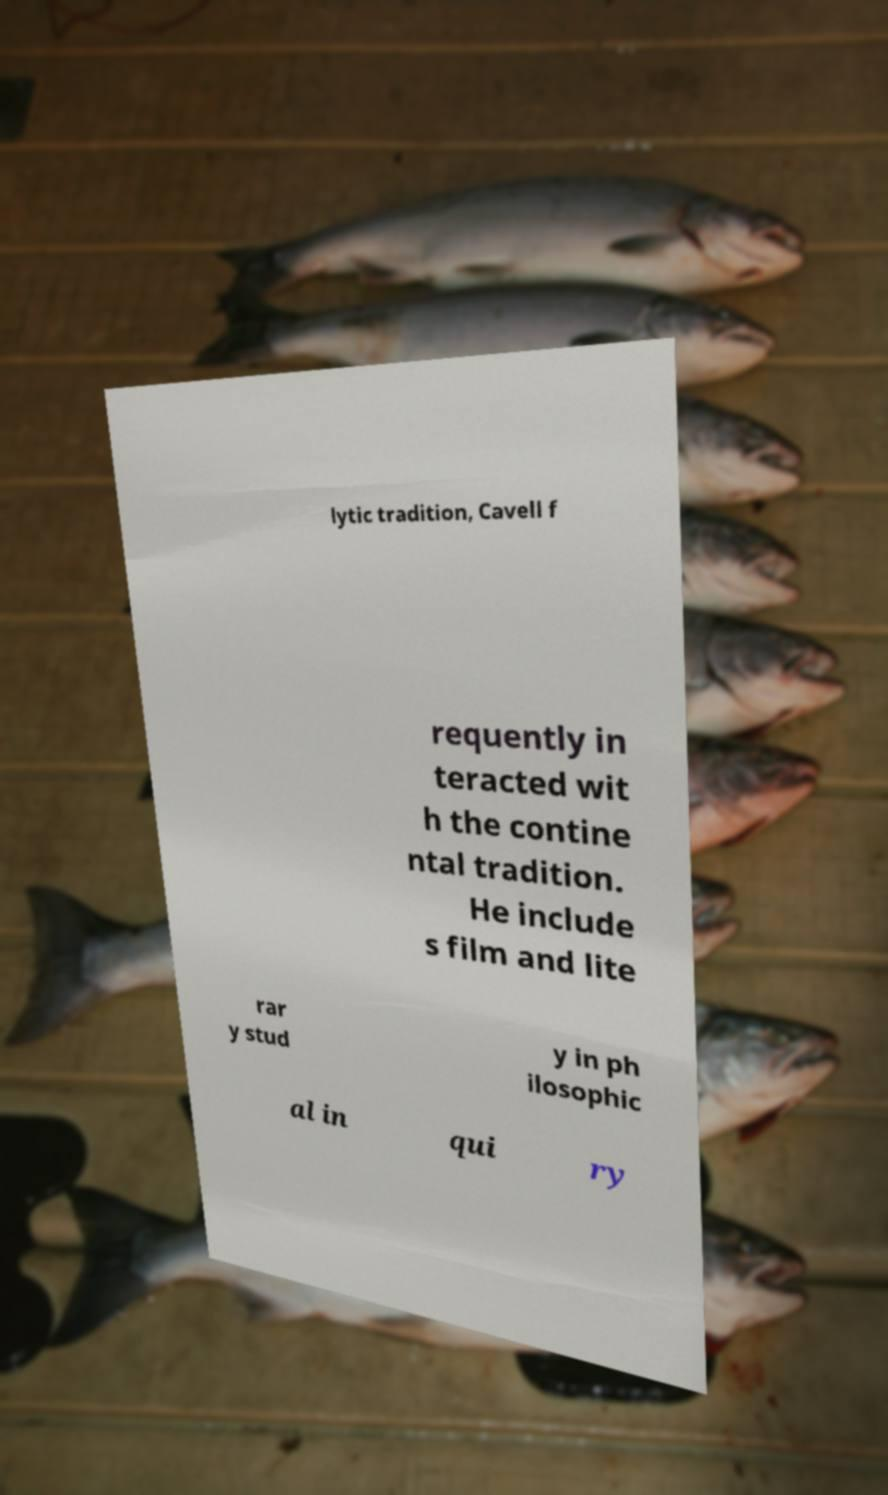Can you read and provide the text displayed in the image?This photo seems to have some interesting text. Can you extract and type it out for me? lytic tradition, Cavell f requently in teracted wit h the contine ntal tradition. He include s film and lite rar y stud y in ph ilosophic al in qui ry 